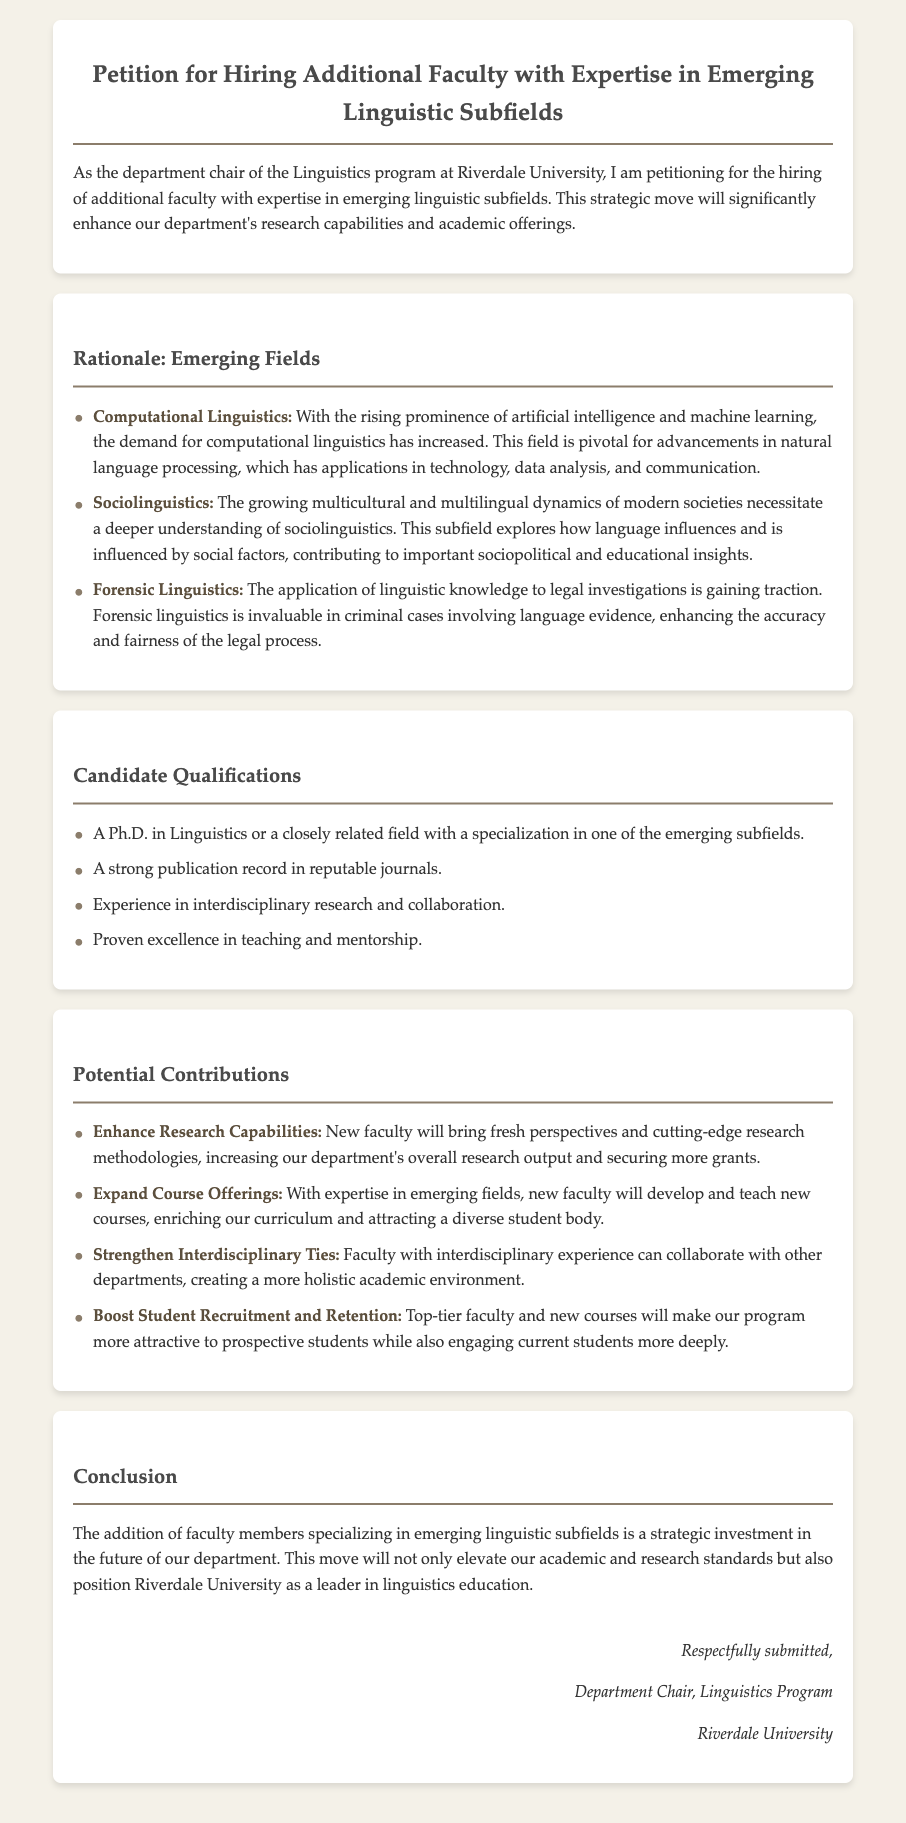What is the title of the petition? The title of the petition is specified in the header of the document.
Answer: Petition for Hiring Additional Faculty with Expertise in Emerging Linguistic Subfields What subfield focuses on language and artificial intelligence? The document mentions computational linguistics as the subfield related to artificial intelligence.
Answer: Computational Linguistics What is one of the candidate qualifications listed? The document provides several qualifications for candidates, which are explicitly listed under qualifications.
Answer: A Ph.D. in Linguistics How many emerging linguistic subfields are mentioned in the document? The document outlines three specific emerging linguistic subfields in the rationale section.
Answer: Three What potential contribution could enhance research capabilities? The potential contributions in the document reference new faculty bringing fresh perspectives and research methodologies.
Answer: Enhance Research Capabilities What institution is the petition addressed from? The petition identifies Riverdale University as the institution from which the department chair is submitting the request.
Answer: Riverdale University What is one reason stated for hiring additional faculty? The reasoning for hiring additional faculty includes several strategic benefits, as outlined in the rationale section.
Answer: Enhance our department's research capabilities What will new faculty potentially help boost? The document states that new faculty will make the program more attractive, which relates to student engagement.
Answer: Student Recruitment and Retention 